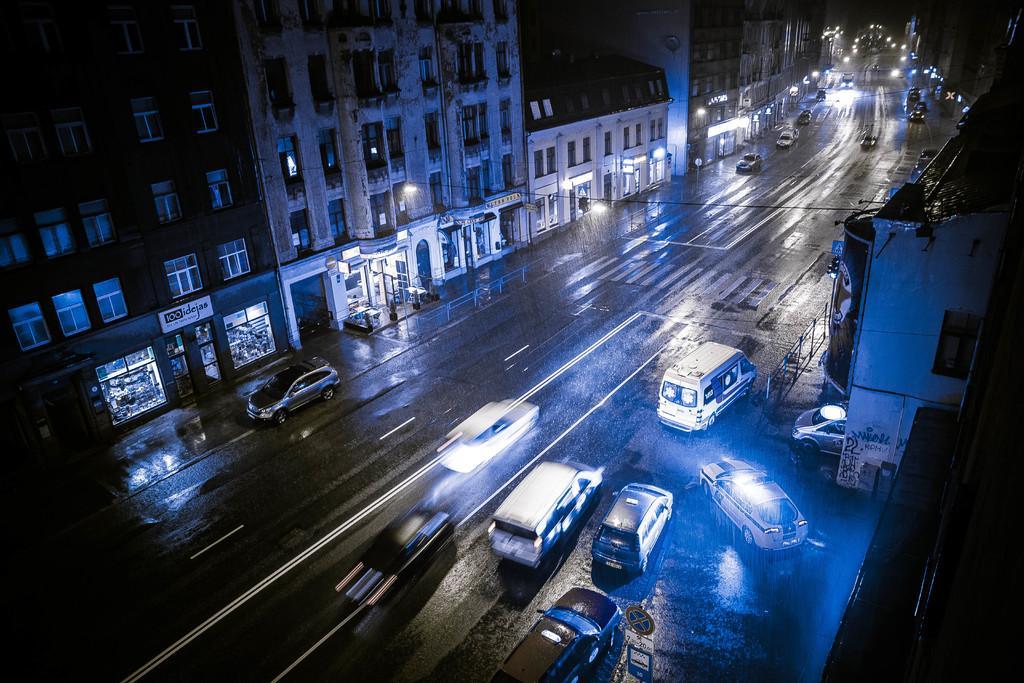Describe this image in one or two sentences. There are vehicles on the road. On both sides of this road, there are buildings. And the background is dark in color. 